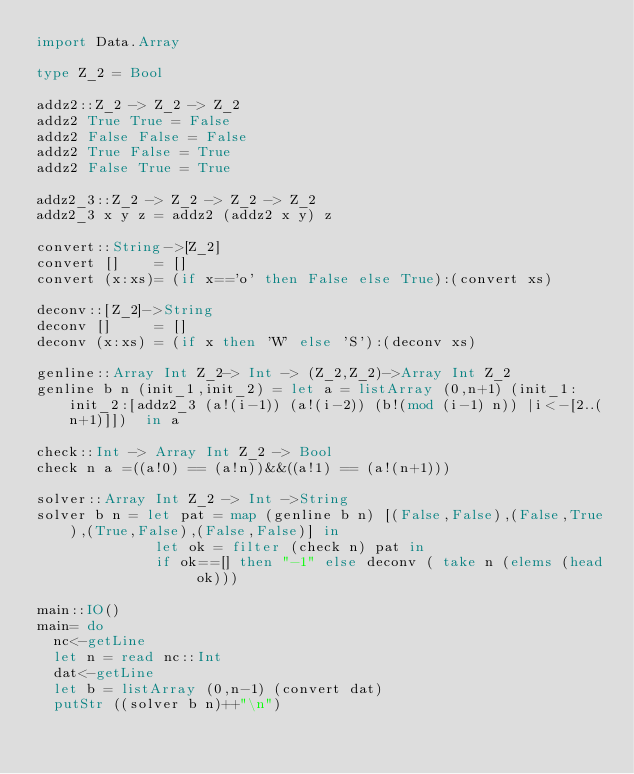Convert code to text. <code><loc_0><loc_0><loc_500><loc_500><_Haskell_>import Data.Array

type Z_2 = Bool

addz2::Z_2 -> Z_2 -> Z_2
addz2 True True = False
addz2 False False = False
addz2 True False = True
addz2 False True = True

addz2_3::Z_2 -> Z_2 -> Z_2 -> Z_2
addz2_3 x y z = addz2 (addz2 x y) z

convert::String->[Z_2]
convert []    = []
convert (x:xs)= (if x=='o' then False else True):(convert xs)

deconv::[Z_2]->String
deconv []     = []
deconv (x:xs) = (if x then 'W' else 'S'):(deconv xs)

genline::Array Int Z_2-> Int -> (Z_2,Z_2)->Array Int Z_2
genline b n (init_1,init_2) = let a = listArray (0,n+1) (init_1:init_2:[addz2_3 (a!(i-1)) (a!(i-2)) (b!(mod (i-1) n)) |i<-[2..(n+1)]])  in a

check::Int -> Array Int Z_2 -> Bool
check n a =((a!0) == (a!n))&&((a!1) == (a!(n+1)))

solver::Array Int Z_2 -> Int ->String
solver b n = let pat = map (genline b n) [(False,False),(False,True),(True,False),(False,False)] in
              let ok = filter (check n) pat in
              if ok==[] then "-1" else deconv ( take n (elems (head ok)))

main::IO()
main= do
  nc<-getLine
  let n = read nc::Int
  dat<-getLine
  let b = listArray (0,n-1) (convert dat)
  putStr ((solver b n)++"\n")
</code> 